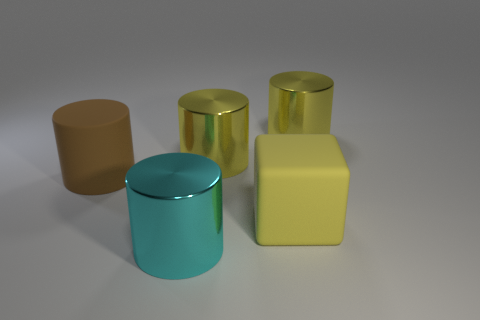The large thing that is the same material as the large block is what color?
Offer a terse response. Brown. Is the number of large cyan things less than the number of green cubes?
Your answer should be very brief. No. There is a big yellow object in front of the brown rubber cylinder that is behind the yellow thing that is in front of the brown object; what is it made of?
Your answer should be very brief. Rubber. What is the cyan object made of?
Provide a short and direct response. Metal. There is a object in front of the large rubber cube; is its color the same as the matte object on the left side of the cyan shiny cylinder?
Your answer should be very brief. No. Are there more big rubber cubes than large yellow shiny objects?
Give a very brief answer. No. How many large objects have the same color as the large rubber cube?
Your response must be concise. 2. What is the color of the matte thing that is the same shape as the big cyan metallic thing?
Your answer should be compact. Brown. The object that is both on the left side of the matte block and in front of the brown thing is made of what material?
Your response must be concise. Metal. Does the big yellow cylinder that is to the left of the rubber cube have the same material as the object to the right of the big yellow block?
Your answer should be very brief. Yes. 